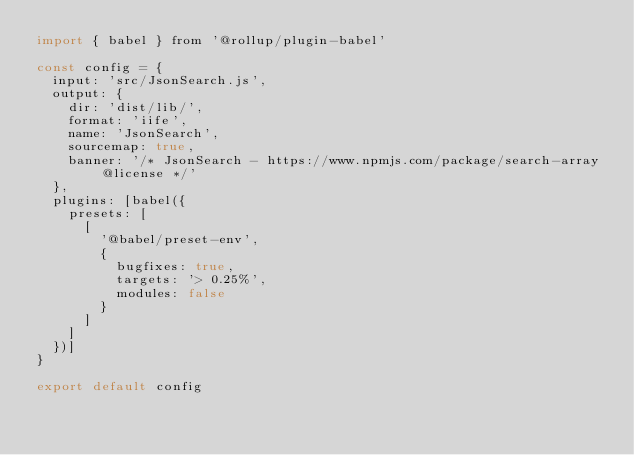<code> <loc_0><loc_0><loc_500><loc_500><_JavaScript_>import { babel } from '@rollup/plugin-babel'

const config = {
  input: 'src/JsonSearch.js',
  output: {
    dir: 'dist/lib/',
    format: 'iife',
    name: 'JsonSearch',
    sourcemap: true,
    banner: '/* JsonSearch - https://www.npmjs.com/package/search-array @license */'
  },
  plugins: [babel({
    presets: [
      [
        '@babel/preset-env',
        {
          bugfixes: true,
          targets: '> 0.25%',
          modules: false
        }
      ]
    ]
  })]
}

export default config
</code> 